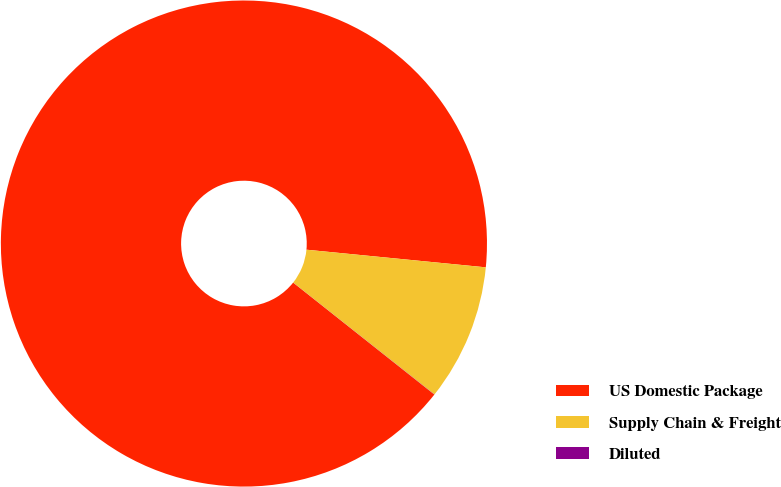Convert chart. <chart><loc_0><loc_0><loc_500><loc_500><pie_chart><fcel>US Domestic Package<fcel>Supply Chain & Freight<fcel>Diluted<nl><fcel>90.89%<fcel>9.1%<fcel>0.01%<nl></chart> 